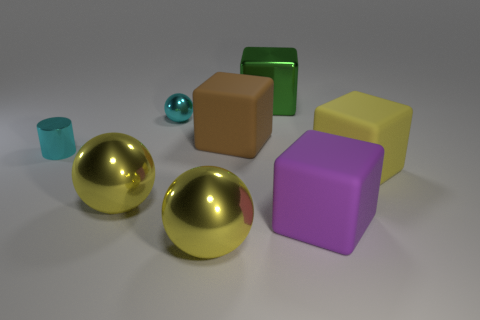How many big yellow cubes are there?
Your answer should be very brief. 1. What shape is the object that is both right of the green cube and in front of the large yellow rubber object?
Keep it short and to the point. Cube. Do the block that is left of the green object and the metallic object on the right side of the brown matte object have the same color?
Ensure brevity in your answer.  No. What is the size of the metallic ball that is the same color as the cylinder?
Provide a succinct answer. Small. Are there any big blocks that have the same material as the cyan sphere?
Provide a succinct answer. Yes. Are there an equal number of big yellow metallic spheres behind the big purple thing and metal objects that are in front of the shiny block?
Your answer should be compact. No. There is a matte cube behind the small cyan metal cylinder; what is its size?
Offer a terse response. Large. There is a thing that is behind the cyan object that is behind the big brown object; what is it made of?
Keep it short and to the point. Metal. There is a small shiny thing behind the matte object that is to the left of the big purple rubber object; how many yellow matte things are on the left side of it?
Ensure brevity in your answer.  0. Is the material of the large yellow object that is to the right of the large purple rubber block the same as the yellow sphere that is to the right of the cyan ball?
Ensure brevity in your answer.  No. 